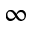<formula> <loc_0><loc_0><loc_500><loc_500>\infty</formula> 